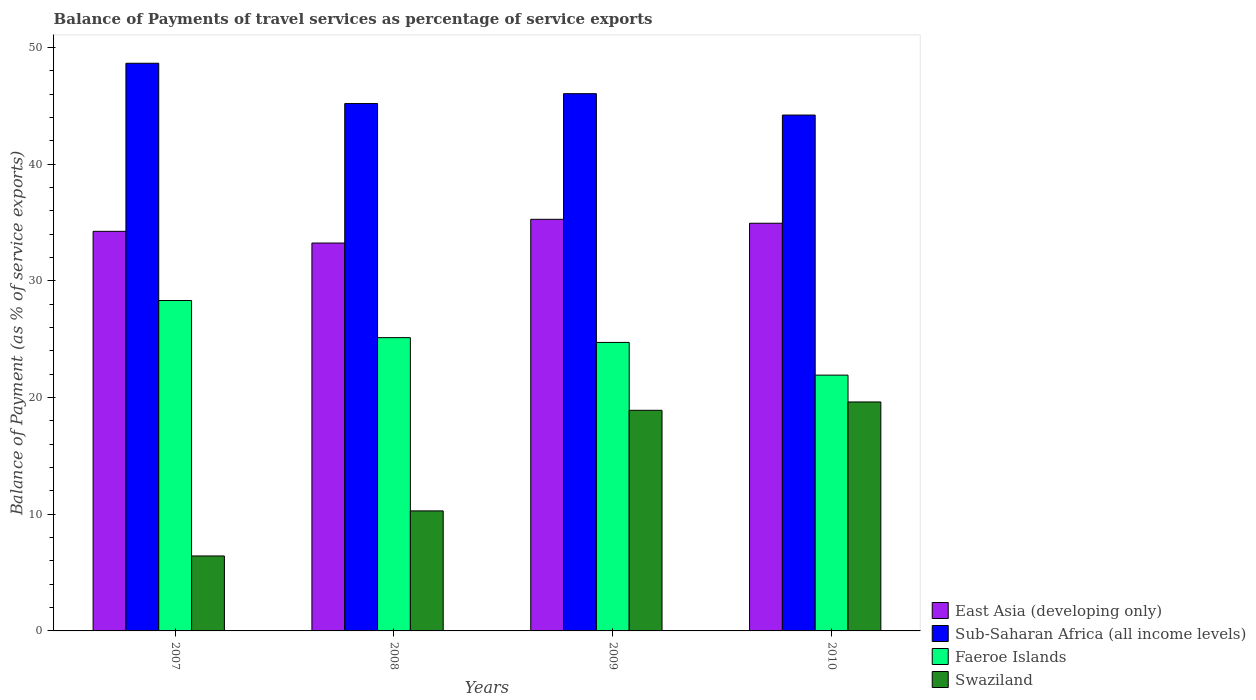How many groups of bars are there?
Provide a succinct answer. 4. Are the number of bars per tick equal to the number of legend labels?
Provide a short and direct response. Yes. In how many cases, is the number of bars for a given year not equal to the number of legend labels?
Ensure brevity in your answer.  0. What is the balance of payments of travel services in East Asia (developing only) in 2008?
Ensure brevity in your answer.  33.23. Across all years, what is the maximum balance of payments of travel services in Faeroe Islands?
Make the answer very short. 28.31. Across all years, what is the minimum balance of payments of travel services in Faeroe Islands?
Make the answer very short. 21.92. In which year was the balance of payments of travel services in Faeroe Islands maximum?
Your answer should be very brief. 2007. In which year was the balance of payments of travel services in Faeroe Islands minimum?
Your answer should be compact. 2010. What is the total balance of payments of travel services in Swaziland in the graph?
Ensure brevity in your answer.  55.23. What is the difference between the balance of payments of travel services in Swaziland in 2008 and that in 2009?
Provide a succinct answer. -8.62. What is the difference between the balance of payments of travel services in Faeroe Islands in 2010 and the balance of payments of travel services in East Asia (developing only) in 2009?
Give a very brief answer. -13.35. What is the average balance of payments of travel services in East Asia (developing only) per year?
Keep it short and to the point. 34.42. In the year 2009, what is the difference between the balance of payments of travel services in Swaziland and balance of payments of travel services in Sub-Saharan Africa (all income levels)?
Keep it short and to the point. -27.13. In how many years, is the balance of payments of travel services in Faeroe Islands greater than 32 %?
Offer a very short reply. 0. What is the ratio of the balance of payments of travel services in Sub-Saharan Africa (all income levels) in 2008 to that in 2009?
Provide a short and direct response. 0.98. Is the balance of payments of travel services in East Asia (developing only) in 2007 less than that in 2010?
Your answer should be compact. Yes. Is the difference between the balance of payments of travel services in Swaziland in 2007 and 2009 greater than the difference between the balance of payments of travel services in Sub-Saharan Africa (all income levels) in 2007 and 2009?
Provide a short and direct response. No. What is the difference between the highest and the second highest balance of payments of travel services in East Asia (developing only)?
Provide a succinct answer. 0.34. What is the difference between the highest and the lowest balance of payments of travel services in East Asia (developing only)?
Give a very brief answer. 2.03. Is the sum of the balance of payments of travel services in East Asia (developing only) in 2009 and 2010 greater than the maximum balance of payments of travel services in Sub-Saharan Africa (all income levels) across all years?
Keep it short and to the point. Yes. Is it the case that in every year, the sum of the balance of payments of travel services in Faeroe Islands and balance of payments of travel services in East Asia (developing only) is greater than the sum of balance of payments of travel services in Sub-Saharan Africa (all income levels) and balance of payments of travel services in Swaziland?
Give a very brief answer. No. What does the 4th bar from the left in 2008 represents?
Make the answer very short. Swaziland. What does the 3rd bar from the right in 2007 represents?
Your answer should be very brief. Sub-Saharan Africa (all income levels). Is it the case that in every year, the sum of the balance of payments of travel services in Swaziland and balance of payments of travel services in East Asia (developing only) is greater than the balance of payments of travel services in Faeroe Islands?
Provide a succinct answer. Yes. How many years are there in the graph?
Keep it short and to the point. 4. What is the difference between two consecutive major ticks on the Y-axis?
Offer a very short reply. 10. Are the values on the major ticks of Y-axis written in scientific E-notation?
Offer a terse response. No. Does the graph contain any zero values?
Give a very brief answer. No. How are the legend labels stacked?
Make the answer very short. Vertical. What is the title of the graph?
Provide a succinct answer. Balance of Payments of travel services as percentage of service exports. What is the label or title of the Y-axis?
Provide a short and direct response. Balance of Payment (as % of service exports). What is the Balance of Payment (as % of service exports) in East Asia (developing only) in 2007?
Provide a short and direct response. 34.24. What is the Balance of Payment (as % of service exports) in Sub-Saharan Africa (all income levels) in 2007?
Ensure brevity in your answer.  48.64. What is the Balance of Payment (as % of service exports) in Faeroe Islands in 2007?
Give a very brief answer. 28.31. What is the Balance of Payment (as % of service exports) of Swaziland in 2007?
Offer a very short reply. 6.42. What is the Balance of Payment (as % of service exports) of East Asia (developing only) in 2008?
Make the answer very short. 33.23. What is the Balance of Payment (as % of service exports) in Sub-Saharan Africa (all income levels) in 2008?
Make the answer very short. 45.19. What is the Balance of Payment (as % of service exports) in Faeroe Islands in 2008?
Offer a very short reply. 25.13. What is the Balance of Payment (as % of service exports) in Swaziland in 2008?
Keep it short and to the point. 10.28. What is the Balance of Payment (as % of service exports) of East Asia (developing only) in 2009?
Keep it short and to the point. 35.27. What is the Balance of Payment (as % of service exports) of Sub-Saharan Africa (all income levels) in 2009?
Give a very brief answer. 46.03. What is the Balance of Payment (as % of service exports) of Faeroe Islands in 2009?
Your answer should be very brief. 24.72. What is the Balance of Payment (as % of service exports) of Swaziland in 2009?
Make the answer very short. 18.9. What is the Balance of Payment (as % of service exports) of East Asia (developing only) in 2010?
Provide a short and direct response. 34.93. What is the Balance of Payment (as % of service exports) of Sub-Saharan Africa (all income levels) in 2010?
Ensure brevity in your answer.  44.2. What is the Balance of Payment (as % of service exports) of Faeroe Islands in 2010?
Offer a very short reply. 21.92. What is the Balance of Payment (as % of service exports) in Swaziland in 2010?
Ensure brevity in your answer.  19.62. Across all years, what is the maximum Balance of Payment (as % of service exports) of East Asia (developing only)?
Provide a succinct answer. 35.27. Across all years, what is the maximum Balance of Payment (as % of service exports) of Sub-Saharan Africa (all income levels)?
Provide a short and direct response. 48.64. Across all years, what is the maximum Balance of Payment (as % of service exports) of Faeroe Islands?
Keep it short and to the point. 28.31. Across all years, what is the maximum Balance of Payment (as % of service exports) in Swaziland?
Give a very brief answer. 19.62. Across all years, what is the minimum Balance of Payment (as % of service exports) of East Asia (developing only)?
Your response must be concise. 33.23. Across all years, what is the minimum Balance of Payment (as % of service exports) of Sub-Saharan Africa (all income levels)?
Offer a terse response. 44.2. Across all years, what is the minimum Balance of Payment (as % of service exports) in Faeroe Islands?
Keep it short and to the point. 21.92. Across all years, what is the minimum Balance of Payment (as % of service exports) of Swaziland?
Keep it short and to the point. 6.42. What is the total Balance of Payment (as % of service exports) in East Asia (developing only) in the graph?
Your answer should be very brief. 137.67. What is the total Balance of Payment (as % of service exports) of Sub-Saharan Africa (all income levels) in the graph?
Keep it short and to the point. 184.06. What is the total Balance of Payment (as % of service exports) in Faeroe Islands in the graph?
Your answer should be compact. 100.07. What is the total Balance of Payment (as % of service exports) of Swaziland in the graph?
Provide a short and direct response. 55.23. What is the difference between the Balance of Payment (as % of service exports) in East Asia (developing only) in 2007 and that in 2008?
Give a very brief answer. 1. What is the difference between the Balance of Payment (as % of service exports) in Sub-Saharan Africa (all income levels) in 2007 and that in 2008?
Ensure brevity in your answer.  3.45. What is the difference between the Balance of Payment (as % of service exports) of Faeroe Islands in 2007 and that in 2008?
Your answer should be very brief. 3.18. What is the difference between the Balance of Payment (as % of service exports) of Swaziland in 2007 and that in 2008?
Provide a short and direct response. -3.86. What is the difference between the Balance of Payment (as % of service exports) in East Asia (developing only) in 2007 and that in 2009?
Provide a succinct answer. -1.03. What is the difference between the Balance of Payment (as % of service exports) of Sub-Saharan Africa (all income levels) in 2007 and that in 2009?
Ensure brevity in your answer.  2.61. What is the difference between the Balance of Payment (as % of service exports) of Faeroe Islands in 2007 and that in 2009?
Give a very brief answer. 3.59. What is the difference between the Balance of Payment (as % of service exports) in Swaziland in 2007 and that in 2009?
Provide a short and direct response. -12.48. What is the difference between the Balance of Payment (as % of service exports) of East Asia (developing only) in 2007 and that in 2010?
Give a very brief answer. -0.69. What is the difference between the Balance of Payment (as % of service exports) in Sub-Saharan Africa (all income levels) in 2007 and that in 2010?
Keep it short and to the point. 4.44. What is the difference between the Balance of Payment (as % of service exports) in Faeroe Islands in 2007 and that in 2010?
Ensure brevity in your answer.  6.39. What is the difference between the Balance of Payment (as % of service exports) of Swaziland in 2007 and that in 2010?
Provide a succinct answer. -13.2. What is the difference between the Balance of Payment (as % of service exports) of East Asia (developing only) in 2008 and that in 2009?
Your answer should be compact. -2.03. What is the difference between the Balance of Payment (as % of service exports) in Sub-Saharan Africa (all income levels) in 2008 and that in 2009?
Give a very brief answer. -0.85. What is the difference between the Balance of Payment (as % of service exports) of Faeroe Islands in 2008 and that in 2009?
Give a very brief answer. 0.41. What is the difference between the Balance of Payment (as % of service exports) in Swaziland in 2008 and that in 2009?
Ensure brevity in your answer.  -8.62. What is the difference between the Balance of Payment (as % of service exports) in East Asia (developing only) in 2008 and that in 2010?
Make the answer very short. -1.7. What is the difference between the Balance of Payment (as % of service exports) in Sub-Saharan Africa (all income levels) in 2008 and that in 2010?
Give a very brief answer. 0.99. What is the difference between the Balance of Payment (as % of service exports) in Faeroe Islands in 2008 and that in 2010?
Offer a very short reply. 3.21. What is the difference between the Balance of Payment (as % of service exports) in Swaziland in 2008 and that in 2010?
Your answer should be very brief. -9.33. What is the difference between the Balance of Payment (as % of service exports) in East Asia (developing only) in 2009 and that in 2010?
Give a very brief answer. 0.34. What is the difference between the Balance of Payment (as % of service exports) in Sub-Saharan Africa (all income levels) in 2009 and that in 2010?
Your answer should be compact. 1.83. What is the difference between the Balance of Payment (as % of service exports) of Faeroe Islands in 2009 and that in 2010?
Your answer should be compact. 2.8. What is the difference between the Balance of Payment (as % of service exports) of Swaziland in 2009 and that in 2010?
Provide a succinct answer. -0.72. What is the difference between the Balance of Payment (as % of service exports) in East Asia (developing only) in 2007 and the Balance of Payment (as % of service exports) in Sub-Saharan Africa (all income levels) in 2008?
Offer a terse response. -10.95. What is the difference between the Balance of Payment (as % of service exports) in East Asia (developing only) in 2007 and the Balance of Payment (as % of service exports) in Faeroe Islands in 2008?
Make the answer very short. 9.11. What is the difference between the Balance of Payment (as % of service exports) in East Asia (developing only) in 2007 and the Balance of Payment (as % of service exports) in Swaziland in 2008?
Give a very brief answer. 23.95. What is the difference between the Balance of Payment (as % of service exports) of Sub-Saharan Africa (all income levels) in 2007 and the Balance of Payment (as % of service exports) of Faeroe Islands in 2008?
Your answer should be very brief. 23.51. What is the difference between the Balance of Payment (as % of service exports) of Sub-Saharan Africa (all income levels) in 2007 and the Balance of Payment (as % of service exports) of Swaziland in 2008?
Offer a terse response. 38.35. What is the difference between the Balance of Payment (as % of service exports) of Faeroe Islands in 2007 and the Balance of Payment (as % of service exports) of Swaziland in 2008?
Provide a succinct answer. 18.03. What is the difference between the Balance of Payment (as % of service exports) of East Asia (developing only) in 2007 and the Balance of Payment (as % of service exports) of Sub-Saharan Africa (all income levels) in 2009?
Make the answer very short. -11.8. What is the difference between the Balance of Payment (as % of service exports) in East Asia (developing only) in 2007 and the Balance of Payment (as % of service exports) in Faeroe Islands in 2009?
Offer a very short reply. 9.52. What is the difference between the Balance of Payment (as % of service exports) of East Asia (developing only) in 2007 and the Balance of Payment (as % of service exports) of Swaziland in 2009?
Your answer should be very brief. 15.33. What is the difference between the Balance of Payment (as % of service exports) in Sub-Saharan Africa (all income levels) in 2007 and the Balance of Payment (as % of service exports) in Faeroe Islands in 2009?
Give a very brief answer. 23.92. What is the difference between the Balance of Payment (as % of service exports) in Sub-Saharan Africa (all income levels) in 2007 and the Balance of Payment (as % of service exports) in Swaziland in 2009?
Provide a succinct answer. 29.74. What is the difference between the Balance of Payment (as % of service exports) of Faeroe Islands in 2007 and the Balance of Payment (as % of service exports) of Swaziland in 2009?
Ensure brevity in your answer.  9.41. What is the difference between the Balance of Payment (as % of service exports) of East Asia (developing only) in 2007 and the Balance of Payment (as % of service exports) of Sub-Saharan Africa (all income levels) in 2010?
Keep it short and to the point. -9.96. What is the difference between the Balance of Payment (as % of service exports) of East Asia (developing only) in 2007 and the Balance of Payment (as % of service exports) of Faeroe Islands in 2010?
Your answer should be compact. 12.32. What is the difference between the Balance of Payment (as % of service exports) in East Asia (developing only) in 2007 and the Balance of Payment (as % of service exports) in Swaziland in 2010?
Offer a terse response. 14.62. What is the difference between the Balance of Payment (as % of service exports) in Sub-Saharan Africa (all income levels) in 2007 and the Balance of Payment (as % of service exports) in Faeroe Islands in 2010?
Provide a succinct answer. 26.72. What is the difference between the Balance of Payment (as % of service exports) in Sub-Saharan Africa (all income levels) in 2007 and the Balance of Payment (as % of service exports) in Swaziland in 2010?
Your answer should be compact. 29.02. What is the difference between the Balance of Payment (as % of service exports) of Faeroe Islands in 2007 and the Balance of Payment (as % of service exports) of Swaziland in 2010?
Offer a very short reply. 8.69. What is the difference between the Balance of Payment (as % of service exports) of East Asia (developing only) in 2008 and the Balance of Payment (as % of service exports) of Sub-Saharan Africa (all income levels) in 2009?
Your answer should be compact. -12.8. What is the difference between the Balance of Payment (as % of service exports) of East Asia (developing only) in 2008 and the Balance of Payment (as % of service exports) of Faeroe Islands in 2009?
Your response must be concise. 8.51. What is the difference between the Balance of Payment (as % of service exports) of East Asia (developing only) in 2008 and the Balance of Payment (as % of service exports) of Swaziland in 2009?
Your answer should be compact. 14.33. What is the difference between the Balance of Payment (as % of service exports) in Sub-Saharan Africa (all income levels) in 2008 and the Balance of Payment (as % of service exports) in Faeroe Islands in 2009?
Offer a very short reply. 20.47. What is the difference between the Balance of Payment (as % of service exports) in Sub-Saharan Africa (all income levels) in 2008 and the Balance of Payment (as % of service exports) in Swaziland in 2009?
Your answer should be compact. 26.28. What is the difference between the Balance of Payment (as % of service exports) in Faeroe Islands in 2008 and the Balance of Payment (as % of service exports) in Swaziland in 2009?
Provide a succinct answer. 6.23. What is the difference between the Balance of Payment (as % of service exports) in East Asia (developing only) in 2008 and the Balance of Payment (as % of service exports) in Sub-Saharan Africa (all income levels) in 2010?
Ensure brevity in your answer.  -10.97. What is the difference between the Balance of Payment (as % of service exports) in East Asia (developing only) in 2008 and the Balance of Payment (as % of service exports) in Faeroe Islands in 2010?
Keep it short and to the point. 11.32. What is the difference between the Balance of Payment (as % of service exports) in East Asia (developing only) in 2008 and the Balance of Payment (as % of service exports) in Swaziland in 2010?
Provide a short and direct response. 13.62. What is the difference between the Balance of Payment (as % of service exports) of Sub-Saharan Africa (all income levels) in 2008 and the Balance of Payment (as % of service exports) of Faeroe Islands in 2010?
Offer a very short reply. 23.27. What is the difference between the Balance of Payment (as % of service exports) in Sub-Saharan Africa (all income levels) in 2008 and the Balance of Payment (as % of service exports) in Swaziland in 2010?
Offer a terse response. 25.57. What is the difference between the Balance of Payment (as % of service exports) in Faeroe Islands in 2008 and the Balance of Payment (as % of service exports) in Swaziland in 2010?
Offer a terse response. 5.51. What is the difference between the Balance of Payment (as % of service exports) in East Asia (developing only) in 2009 and the Balance of Payment (as % of service exports) in Sub-Saharan Africa (all income levels) in 2010?
Make the answer very short. -8.93. What is the difference between the Balance of Payment (as % of service exports) in East Asia (developing only) in 2009 and the Balance of Payment (as % of service exports) in Faeroe Islands in 2010?
Provide a short and direct response. 13.35. What is the difference between the Balance of Payment (as % of service exports) of East Asia (developing only) in 2009 and the Balance of Payment (as % of service exports) of Swaziland in 2010?
Offer a very short reply. 15.65. What is the difference between the Balance of Payment (as % of service exports) of Sub-Saharan Africa (all income levels) in 2009 and the Balance of Payment (as % of service exports) of Faeroe Islands in 2010?
Ensure brevity in your answer.  24.11. What is the difference between the Balance of Payment (as % of service exports) in Sub-Saharan Africa (all income levels) in 2009 and the Balance of Payment (as % of service exports) in Swaziland in 2010?
Give a very brief answer. 26.41. What is the difference between the Balance of Payment (as % of service exports) in Faeroe Islands in 2009 and the Balance of Payment (as % of service exports) in Swaziland in 2010?
Your answer should be compact. 5.1. What is the average Balance of Payment (as % of service exports) of East Asia (developing only) per year?
Give a very brief answer. 34.42. What is the average Balance of Payment (as % of service exports) in Sub-Saharan Africa (all income levels) per year?
Provide a succinct answer. 46.01. What is the average Balance of Payment (as % of service exports) in Faeroe Islands per year?
Provide a short and direct response. 25.02. What is the average Balance of Payment (as % of service exports) in Swaziland per year?
Offer a very short reply. 13.81. In the year 2007, what is the difference between the Balance of Payment (as % of service exports) of East Asia (developing only) and Balance of Payment (as % of service exports) of Sub-Saharan Africa (all income levels)?
Your answer should be very brief. -14.4. In the year 2007, what is the difference between the Balance of Payment (as % of service exports) of East Asia (developing only) and Balance of Payment (as % of service exports) of Faeroe Islands?
Provide a short and direct response. 5.93. In the year 2007, what is the difference between the Balance of Payment (as % of service exports) of East Asia (developing only) and Balance of Payment (as % of service exports) of Swaziland?
Offer a terse response. 27.81. In the year 2007, what is the difference between the Balance of Payment (as % of service exports) of Sub-Saharan Africa (all income levels) and Balance of Payment (as % of service exports) of Faeroe Islands?
Your response must be concise. 20.33. In the year 2007, what is the difference between the Balance of Payment (as % of service exports) of Sub-Saharan Africa (all income levels) and Balance of Payment (as % of service exports) of Swaziland?
Provide a short and direct response. 42.22. In the year 2007, what is the difference between the Balance of Payment (as % of service exports) of Faeroe Islands and Balance of Payment (as % of service exports) of Swaziland?
Offer a very short reply. 21.89. In the year 2008, what is the difference between the Balance of Payment (as % of service exports) of East Asia (developing only) and Balance of Payment (as % of service exports) of Sub-Saharan Africa (all income levels)?
Make the answer very short. -11.95. In the year 2008, what is the difference between the Balance of Payment (as % of service exports) of East Asia (developing only) and Balance of Payment (as % of service exports) of Faeroe Islands?
Provide a succinct answer. 8.11. In the year 2008, what is the difference between the Balance of Payment (as % of service exports) of East Asia (developing only) and Balance of Payment (as % of service exports) of Swaziland?
Offer a terse response. 22.95. In the year 2008, what is the difference between the Balance of Payment (as % of service exports) in Sub-Saharan Africa (all income levels) and Balance of Payment (as % of service exports) in Faeroe Islands?
Provide a short and direct response. 20.06. In the year 2008, what is the difference between the Balance of Payment (as % of service exports) of Sub-Saharan Africa (all income levels) and Balance of Payment (as % of service exports) of Swaziland?
Give a very brief answer. 34.9. In the year 2008, what is the difference between the Balance of Payment (as % of service exports) in Faeroe Islands and Balance of Payment (as % of service exports) in Swaziland?
Give a very brief answer. 14.84. In the year 2009, what is the difference between the Balance of Payment (as % of service exports) of East Asia (developing only) and Balance of Payment (as % of service exports) of Sub-Saharan Africa (all income levels)?
Your answer should be very brief. -10.76. In the year 2009, what is the difference between the Balance of Payment (as % of service exports) of East Asia (developing only) and Balance of Payment (as % of service exports) of Faeroe Islands?
Ensure brevity in your answer.  10.55. In the year 2009, what is the difference between the Balance of Payment (as % of service exports) in East Asia (developing only) and Balance of Payment (as % of service exports) in Swaziland?
Your answer should be compact. 16.37. In the year 2009, what is the difference between the Balance of Payment (as % of service exports) of Sub-Saharan Africa (all income levels) and Balance of Payment (as % of service exports) of Faeroe Islands?
Offer a very short reply. 21.31. In the year 2009, what is the difference between the Balance of Payment (as % of service exports) in Sub-Saharan Africa (all income levels) and Balance of Payment (as % of service exports) in Swaziland?
Your answer should be very brief. 27.13. In the year 2009, what is the difference between the Balance of Payment (as % of service exports) in Faeroe Islands and Balance of Payment (as % of service exports) in Swaziland?
Ensure brevity in your answer.  5.82. In the year 2010, what is the difference between the Balance of Payment (as % of service exports) in East Asia (developing only) and Balance of Payment (as % of service exports) in Sub-Saharan Africa (all income levels)?
Your answer should be very brief. -9.27. In the year 2010, what is the difference between the Balance of Payment (as % of service exports) in East Asia (developing only) and Balance of Payment (as % of service exports) in Faeroe Islands?
Keep it short and to the point. 13.01. In the year 2010, what is the difference between the Balance of Payment (as % of service exports) of East Asia (developing only) and Balance of Payment (as % of service exports) of Swaziland?
Offer a terse response. 15.31. In the year 2010, what is the difference between the Balance of Payment (as % of service exports) of Sub-Saharan Africa (all income levels) and Balance of Payment (as % of service exports) of Faeroe Islands?
Your response must be concise. 22.28. In the year 2010, what is the difference between the Balance of Payment (as % of service exports) of Sub-Saharan Africa (all income levels) and Balance of Payment (as % of service exports) of Swaziland?
Offer a terse response. 24.58. In the year 2010, what is the difference between the Balance of Payment (as % of service exports) in Faeroe Islands and Balance of Payment (as % of service exports) in Swaziland?
Your response must be concise. 2.3. What is the ratio of the Balance of Payment (as % of service exports) in East Asia (developing only) in 2007 to that in 2008?
Offer a very short reply. 1.03. What is the ratio of the Balance of Payment (as % of service exports) of Sub-Saharan Africa (all income levels) in 2007 to that in 2008?
Provide a short and direct response. 1.08. What is the ratio of the Balance of Payment (as % of service exports) of Faeroe Islands in 2007 to that in 2008?
Your response must be concise. 1.13. What is the ratio of the Balance of Payment (as % of service exports) in Swaziland in 2007 to that in 2008?
Your answer should be very brief. 0.62. What is the ratio of the Balance of Payment (as % of service exports) of East Asia (developing only) in 2007 to that in 2009?
Your answer should be very brief. 0.97. What is the ratio of the Balance of Payment (as % of service exports) of Sub-Saharan Africa (all income levels) in 2007 to that in 2009?
Keep it short and to the point. 1.06. What is the ratio of the Balance of Payment (as % of service exports) of Faeroe Islands in 2007 to that in 2009?
Your answer should be very brief. 1.15. What is the ratio of the Balance of Payment (as % of service exports) of Swaziland in 2007 to that in 2009?
Make the answer very short. 0.34. What is the ratio of the Balance of Payment (as % of service exports) of East Asia (developing only) in 2007 to that in 2010?
Your response must be concise. 0.98. What is the ratio of the Balance of Payment (as % of service exports) in Sub-Saharan Africa (all income levels) in 2007 to that in 2010?
Ensure brevity in your answer.  1.1. What is the ratio of the Balance of Payment (as % of service exports) of Faeroe Islands in 2007 to that in 2010?
Provide a succinct answer. 1.29. What is the ratio of the Balance of Payment (as % of service exports) in Swaziland in 2007 to that in 2010?
Your response must be concise. 0.33. What is the ratio of the Balance of Payment (as % of service exports) in East Asia (developing only) in 2008 to that in 2009?
Provide a succinct answer. 0.94. What is the ratio of the Balance of Payment (as % of service exports) of Sub-Saharan Africa (all income levels) in 2008 to that in 2009?
Make the answer very short. 0.98. What is the ratio of the Balance of Payment (as % of service exports) of Faeroe Islands in 2008 to that in 2009?
Provide a short and direct response. 1.02. What is the ratio of the Balance of Payment (as % of service exports) of Swaziland in 2008 to that in 2009?
Offer a terse response. 0.54. What is the ratio of the Balance of Payment (as % of service exports) of East Asia (developing only) in 2008 to that in 2010?
Make the answer very short. 0.95. What is the ratio of the Balance of Payment (as % of service exports) of Sub-Saharan Africa (all income levels) in 2008 to that in 2010?
Your answer should be compact. 1.02. What is the ratio of the Balance of Payment (as % of service exports) in Faeroe Islands in 2008 to that in 2010?
Ensure brevity in your answer.  1.15. What is the ratio of the Balance of Payment (as % of service exports) of Swaziland in 2008 to that in 2010?
Give a very brief answer. 0.52. What is the ratio of the Balance of Payment (as % of service exports) of East Asia (developing only) in 2009 to that in 2010?
Provide a short and direct response. 1.01. What is the ratio of the Balance of Payment (as % of service exports) in Sub-Saharan Africa (all income levels) in 2009 to that in 2010?
Give a very brief answer. 1.04. What is the ratio of the Balance of Payment (as % of service exports) in Faeroe Islands in 2009 to that in 2010?
Your response must be concise. 1.13. What is the ratio of the Balance of Payment (as % of service exports) in Swaziland in 2009 to that in 2010?
Ensure brevity in your answer.  0.96. What is the difference between the highest and the second highest Balance of Payment (as % of service exports) of East Asia (developing only)?
Provide a succinct answer. 0.34. What is the difference between the highest and the second highest Balance of Payment (as % of service exports) in Sub-Saharan Africa (all income levels)?
Make the answer very short. 2.61. What is the difference between the highest and the second highest Balance of Payment (as % of service exports) of Faeroe Islands?
Provide a short and direct response. 3.18. What is the difference between the highest and the second highest Balance of Payment (as % of service exports) in Swaziland?
Offer a very short reply. 0.72. What is the difference between the highest and the lowest Balance of Payment (as % of service exports) of East Asia (developing only)?
Your answer should be very brief. 2.03. What is the difference between the highest and the lowest Balance of Payment (as % of service exports) of Sub-Saharan Africa (all income levels)?
Keep it short and to the point. 4.44. What is the difference between the highest and the lowest Balance of Payment (as % of service exports) in Faeroe Islands?
Offer a terse response. 6.39. What is the difference between the highest and the lowest Balance of Payment (as % of service exports) in Swaziland?
Give a very brief answer. 13.2. 